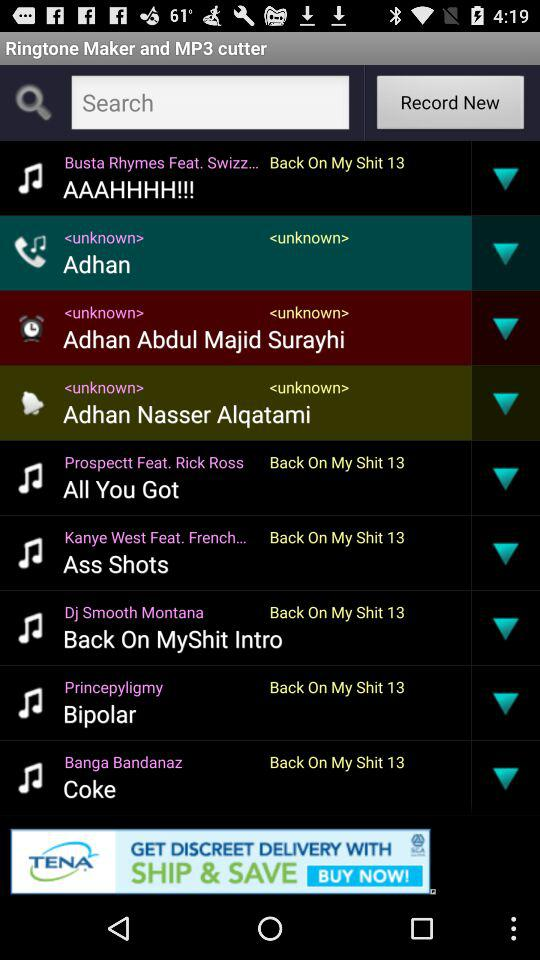Dj Smooth Montana made what ringtone? Dj Smooth Montana made the "Back On Myshit Intro" ringtone. 